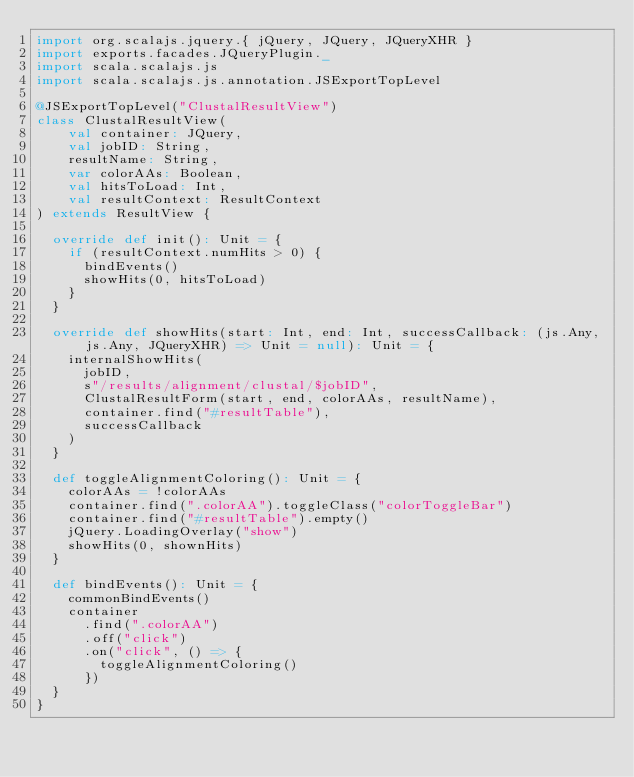Convert code to text. <code><loc_0><loc_0><loc_500><loc_500><_Scala_>import org.scalajs.jquery.{ jQuery, JQuery, JQueryXHR }
import exports.facades.JQueryPlugin._
import scala.scalajs.js
import scala.scalajs.js.annotation.JSExportTopLevel

@JSExportTopLevel("ClustalResultView")
class ClustalResultView(
    val container: JQuery,
    val jobID: String,
    resultName: String,
    var colorAAs: Boolean,
    val hitsToLoad: Int,
    val resultContext: ResultContext
) extends ResultView {

  override def init(): Unit = {
    if (resultContext.numHits > 0) {
      bindEvents()
      showHits(0, hitsToLoad)
    }
  }

  override def showHits(start: Int, end: Int, successCallback: (js.Any, js.Any, JQueryXHR) => Unit = null): Unit = {
    internalShowHits(
      jobID,
      s"/results/alignment/clustal/$jobID",
      ClustalResultForm(start, end, colorAAs, resultName),
      container.find("#resultTable"),
      successCallback
    )
  }

  def toggleAlignmentColoring(): Unit = {
    colorAAs = !colorAAs
    container.find(".colorAA").toggleClass("colorToggleBar")
    container.find("#resultTable").empty()
    jQuery.LoadingOverlay("show")
    showHits(0, shownHits)
  }

  def bindEvents(): Unit = {
    commonBindEvents()
    container
      .find(".colorAA")
      .off("click")
      .on("click", () => {
        toggleAlignmentColoring()
      })
  }
}
</code> 